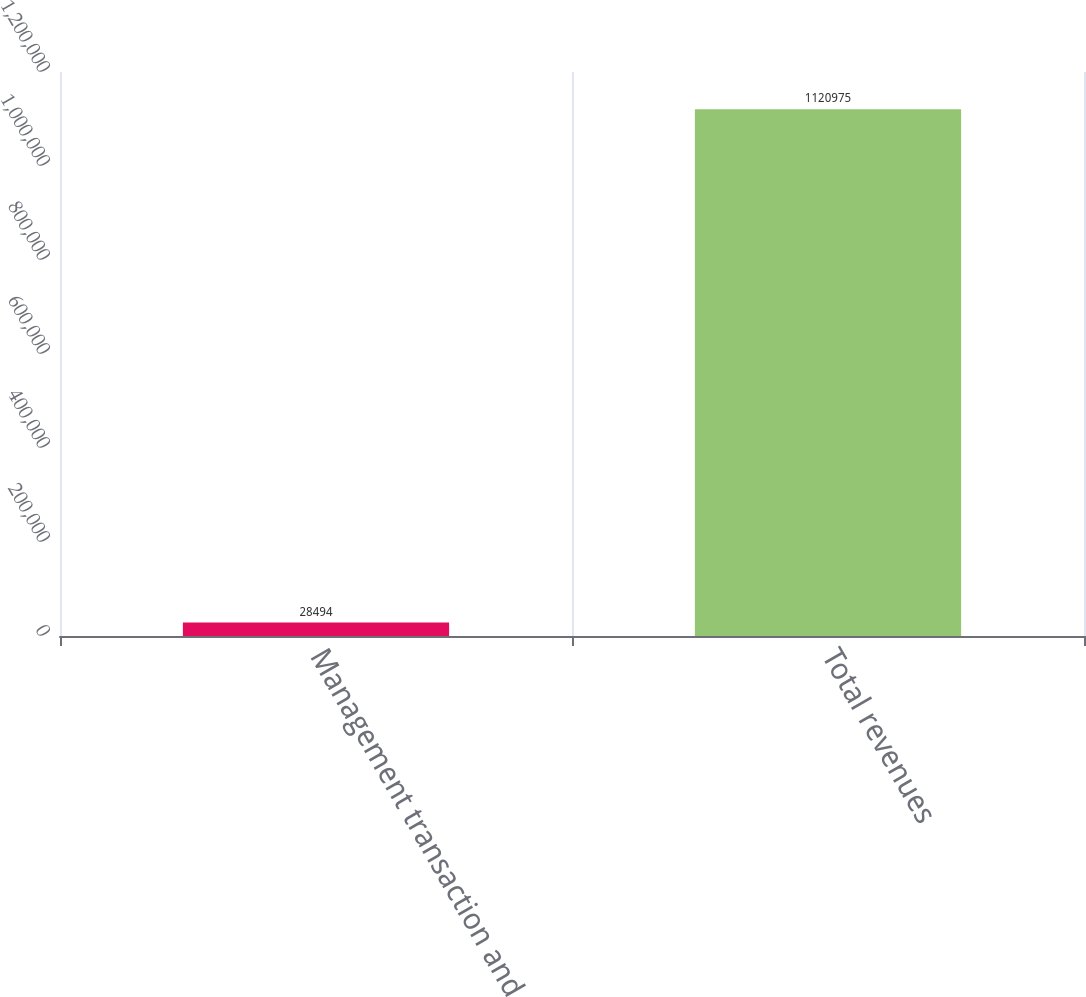<chart> <loc_0><loc_0><loc_500><loc_500><bar_chart><fcel>Management transaction and<fcel>Total revenues<nl><fcel>28494<fcel>1.12098e+06<nl></chart> 